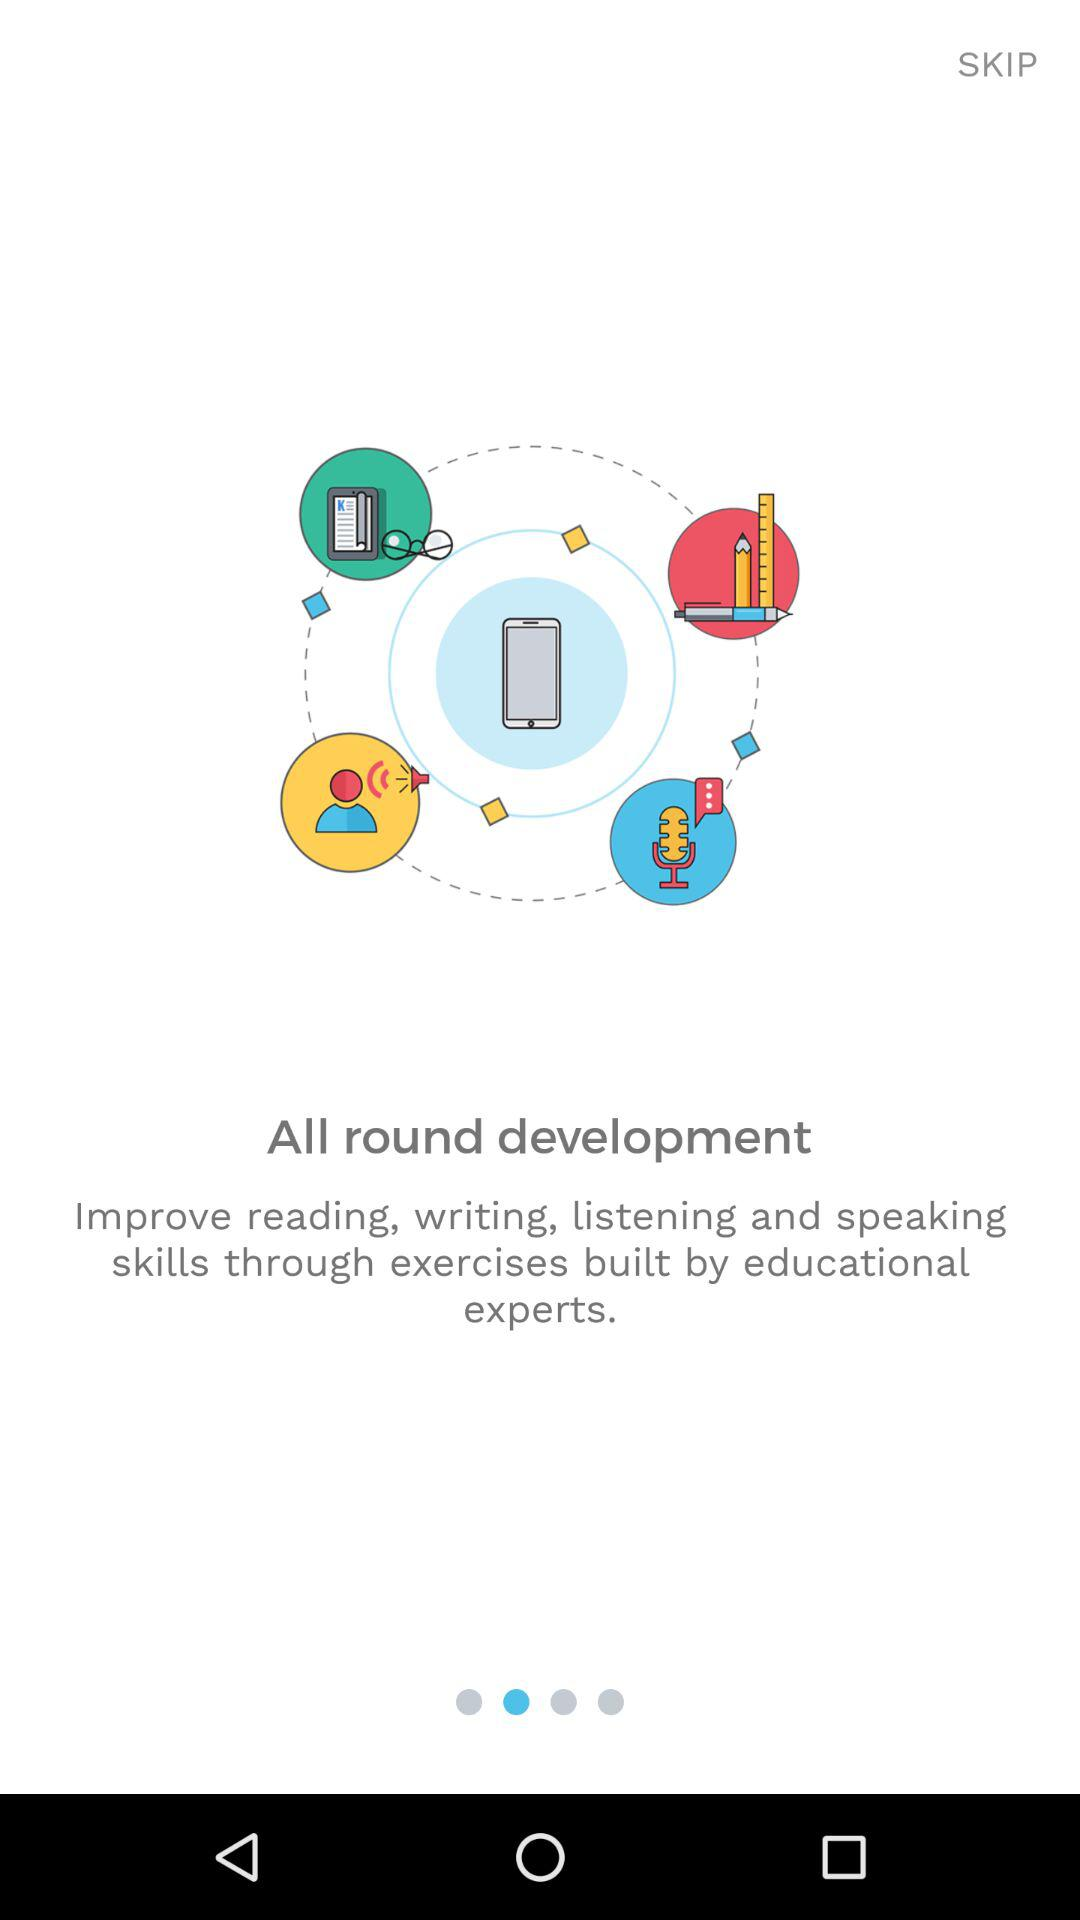What is the application name?
When the provided information is insufficient, respond with <no answer>. <no answer> 